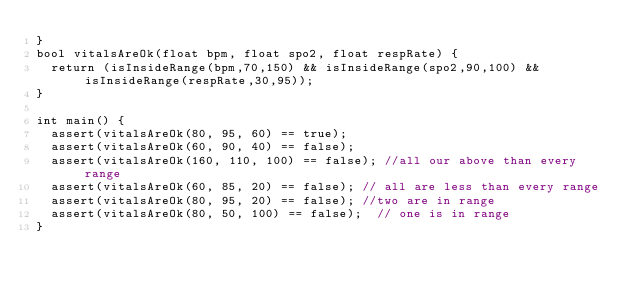<code> <loc_0><loc_0><loc_500><loc_500><_C++_>}
bool vitalsAreOk(float bpm, float spo2, float respRate) {
  return (isInsideRange(bpm,70,150) && isInsideRange(spo2,90,100) && isInsideRange(respRate,30,95));
}
  
int main() {
  assert(vitalsAreOk(80, 95, 60) == true);
  assert(vitalsAreOk(60, 90, 40) == false);
  assert(vitalsAreOk(160, 110, 100) == false); //all our above than every range
  assert(vitalsAreOk(60, 85, 20) == false); // all are less than every range
  assert(vitalsAreOk(80, 95, 20) == false); //two are in range
  assert(vitalsAreOk(80, 50, 100) == false);  // one is in range
}
</code> 